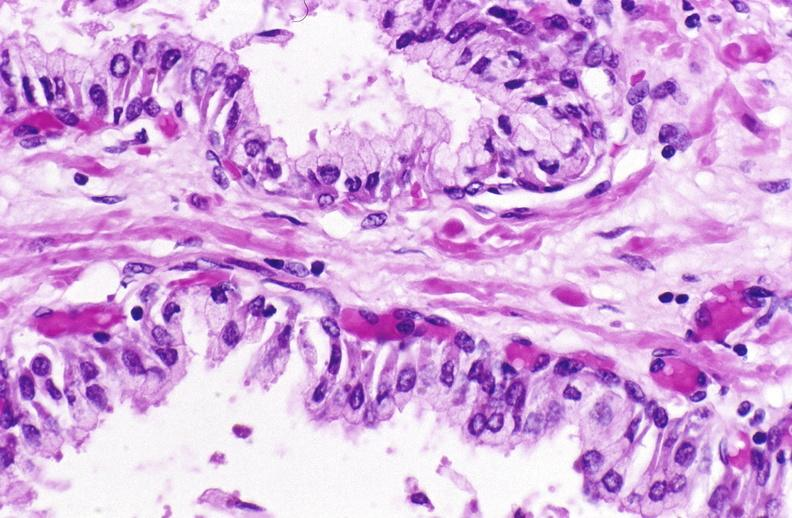does this image show normal prostate?
Answer the question using a single word or phrase. Yes 